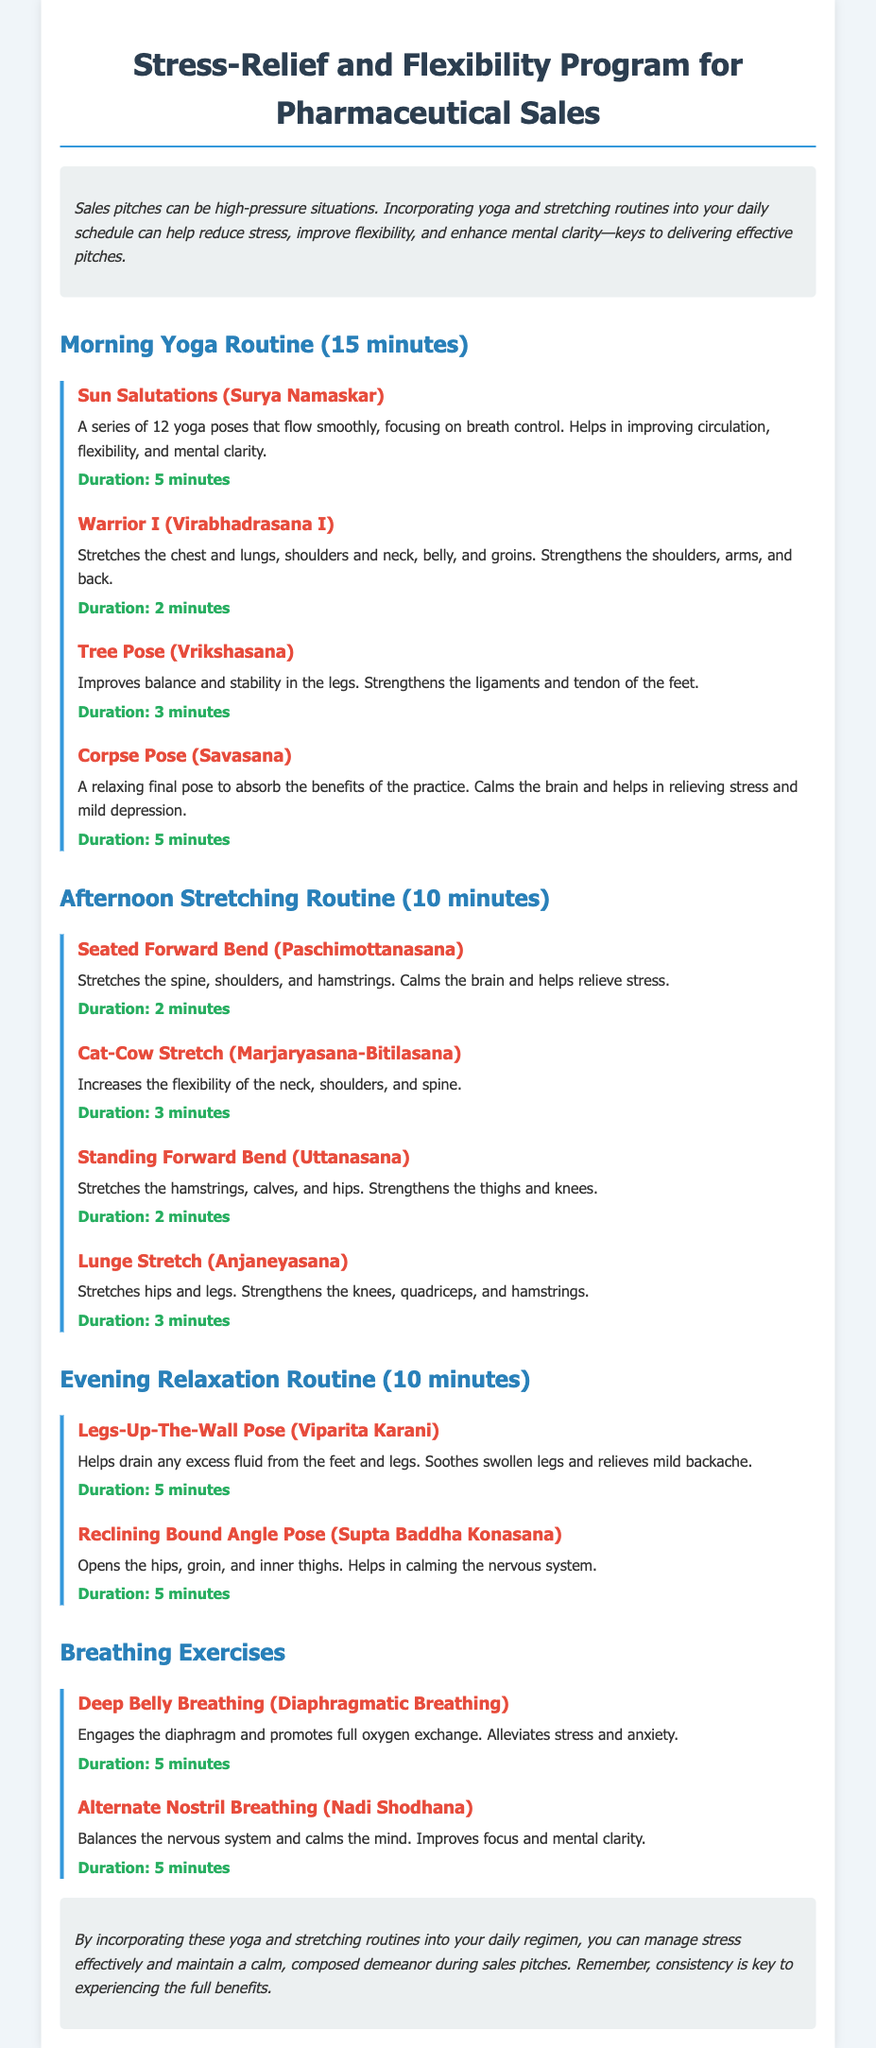what is the title of the program? The title of the program is presented in the header of the document.
Answer: Stress-Relief and Flexibility Program for Pharmaceutical Sales how long is the morning yoga routine? The duration of the morning yoga routine is specified in the document.
Answer: 15 minutes name one exercise included in the afternoon stretching routine. The afternoon stretching routine includes a variety of exercises listed in the document.
Answer: Seated Forward Bend which pose is recommended for evening relaxation? The document lists specific poses under the evening relaxation routine.
Answer: Legs-Up-The-Wall Pose how many minutes should be spent on the Deep Belly Breathing exercise? The duration for the Deep Belly Breathing exercise can be found in the breathing exercises section.
Answer: 5 minutes what does the Warrior I pose strengthen? The benefits of the Warrior I pose are described in the exercise section of the document.
Answer: Shoulders, arms, and back how many exercises are listed in the morning yoga routine? The number of exercises can be counted in the section detailing the morning yoga routine.
Answer: 4 exercises what is the purpose of the Corpse Pose? The benefits related to the Corpse Pose are outlined in the document.
Answer: Calms the brain and helps in relieving stress name one benefit of Alternate Nostril Breathing. The benefits of Alternate Nostril Breathing are described in the corresponding section.
Answer: Balances the nervous system 